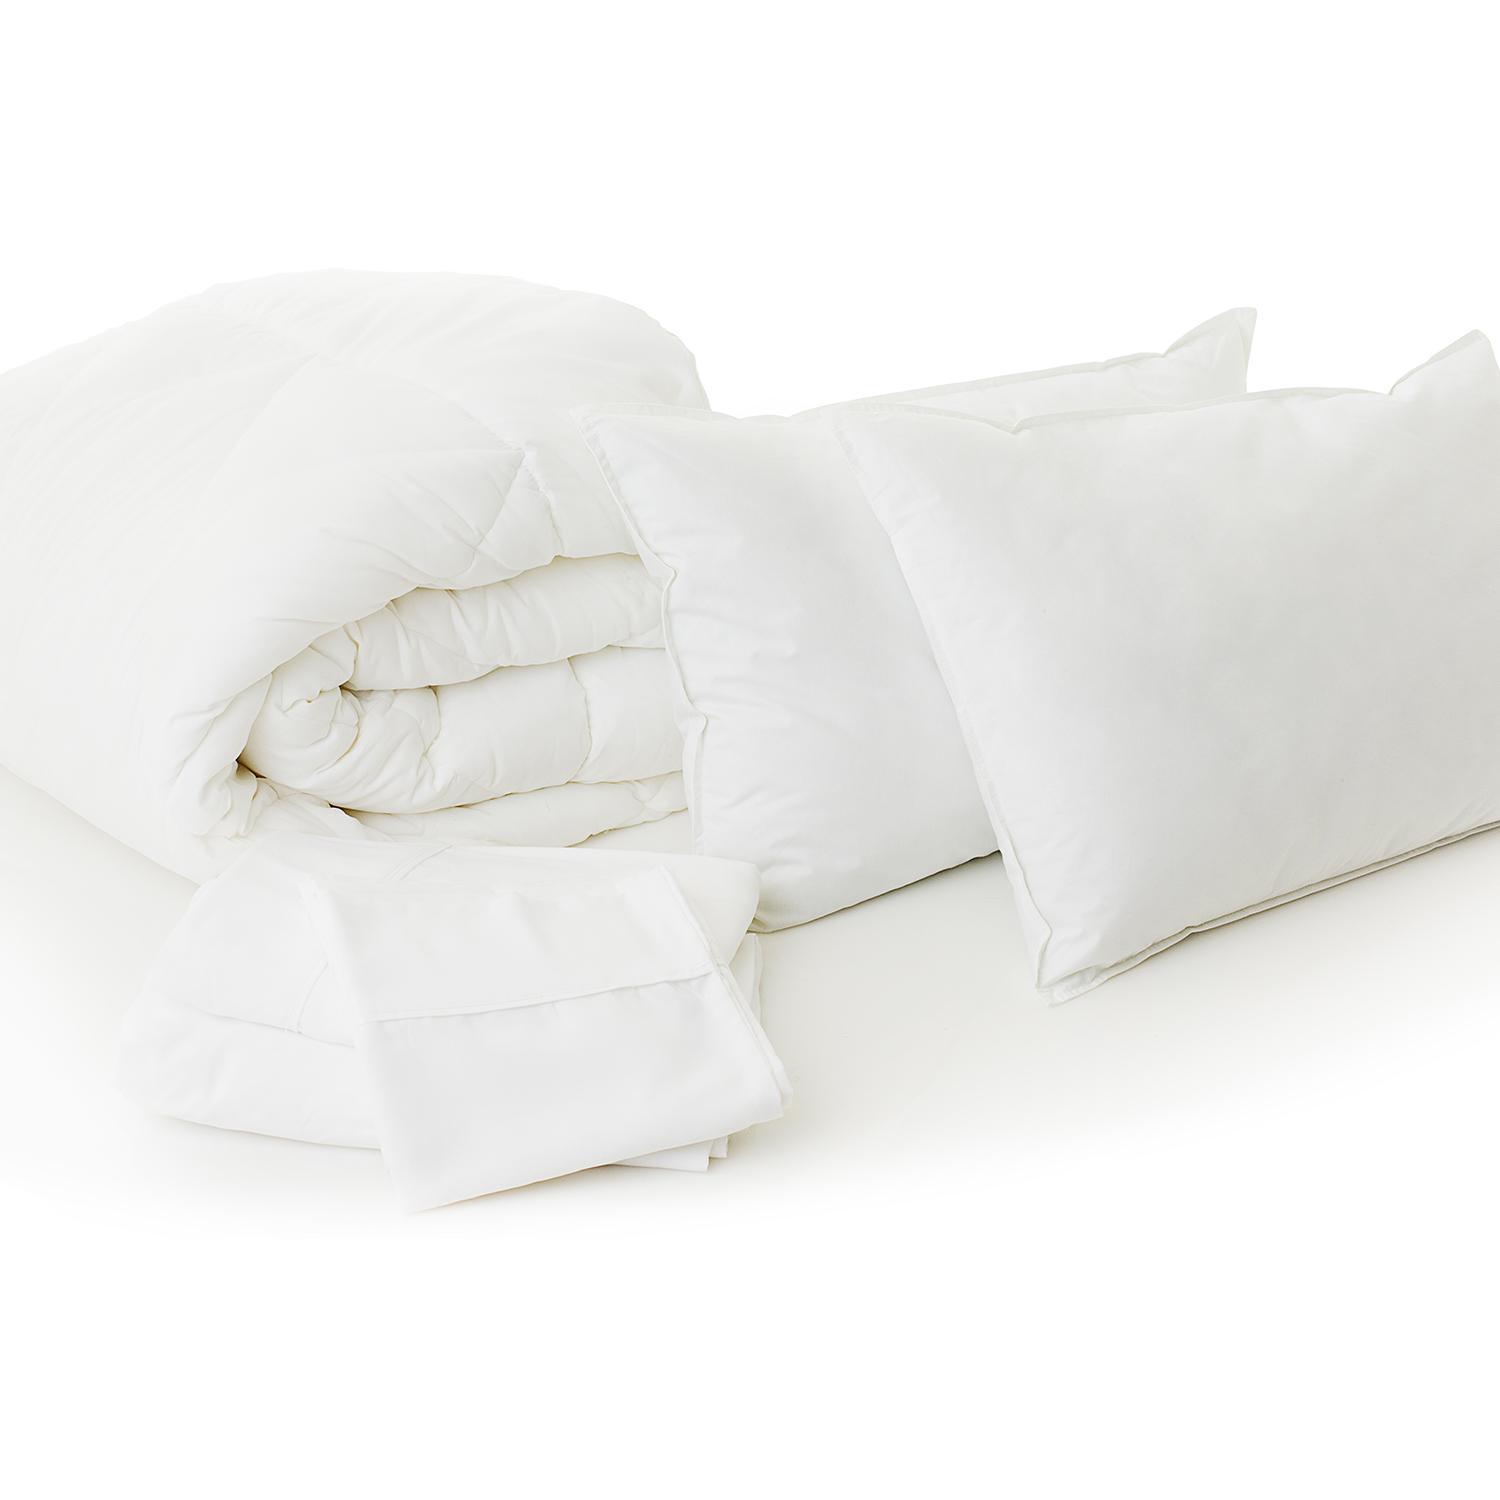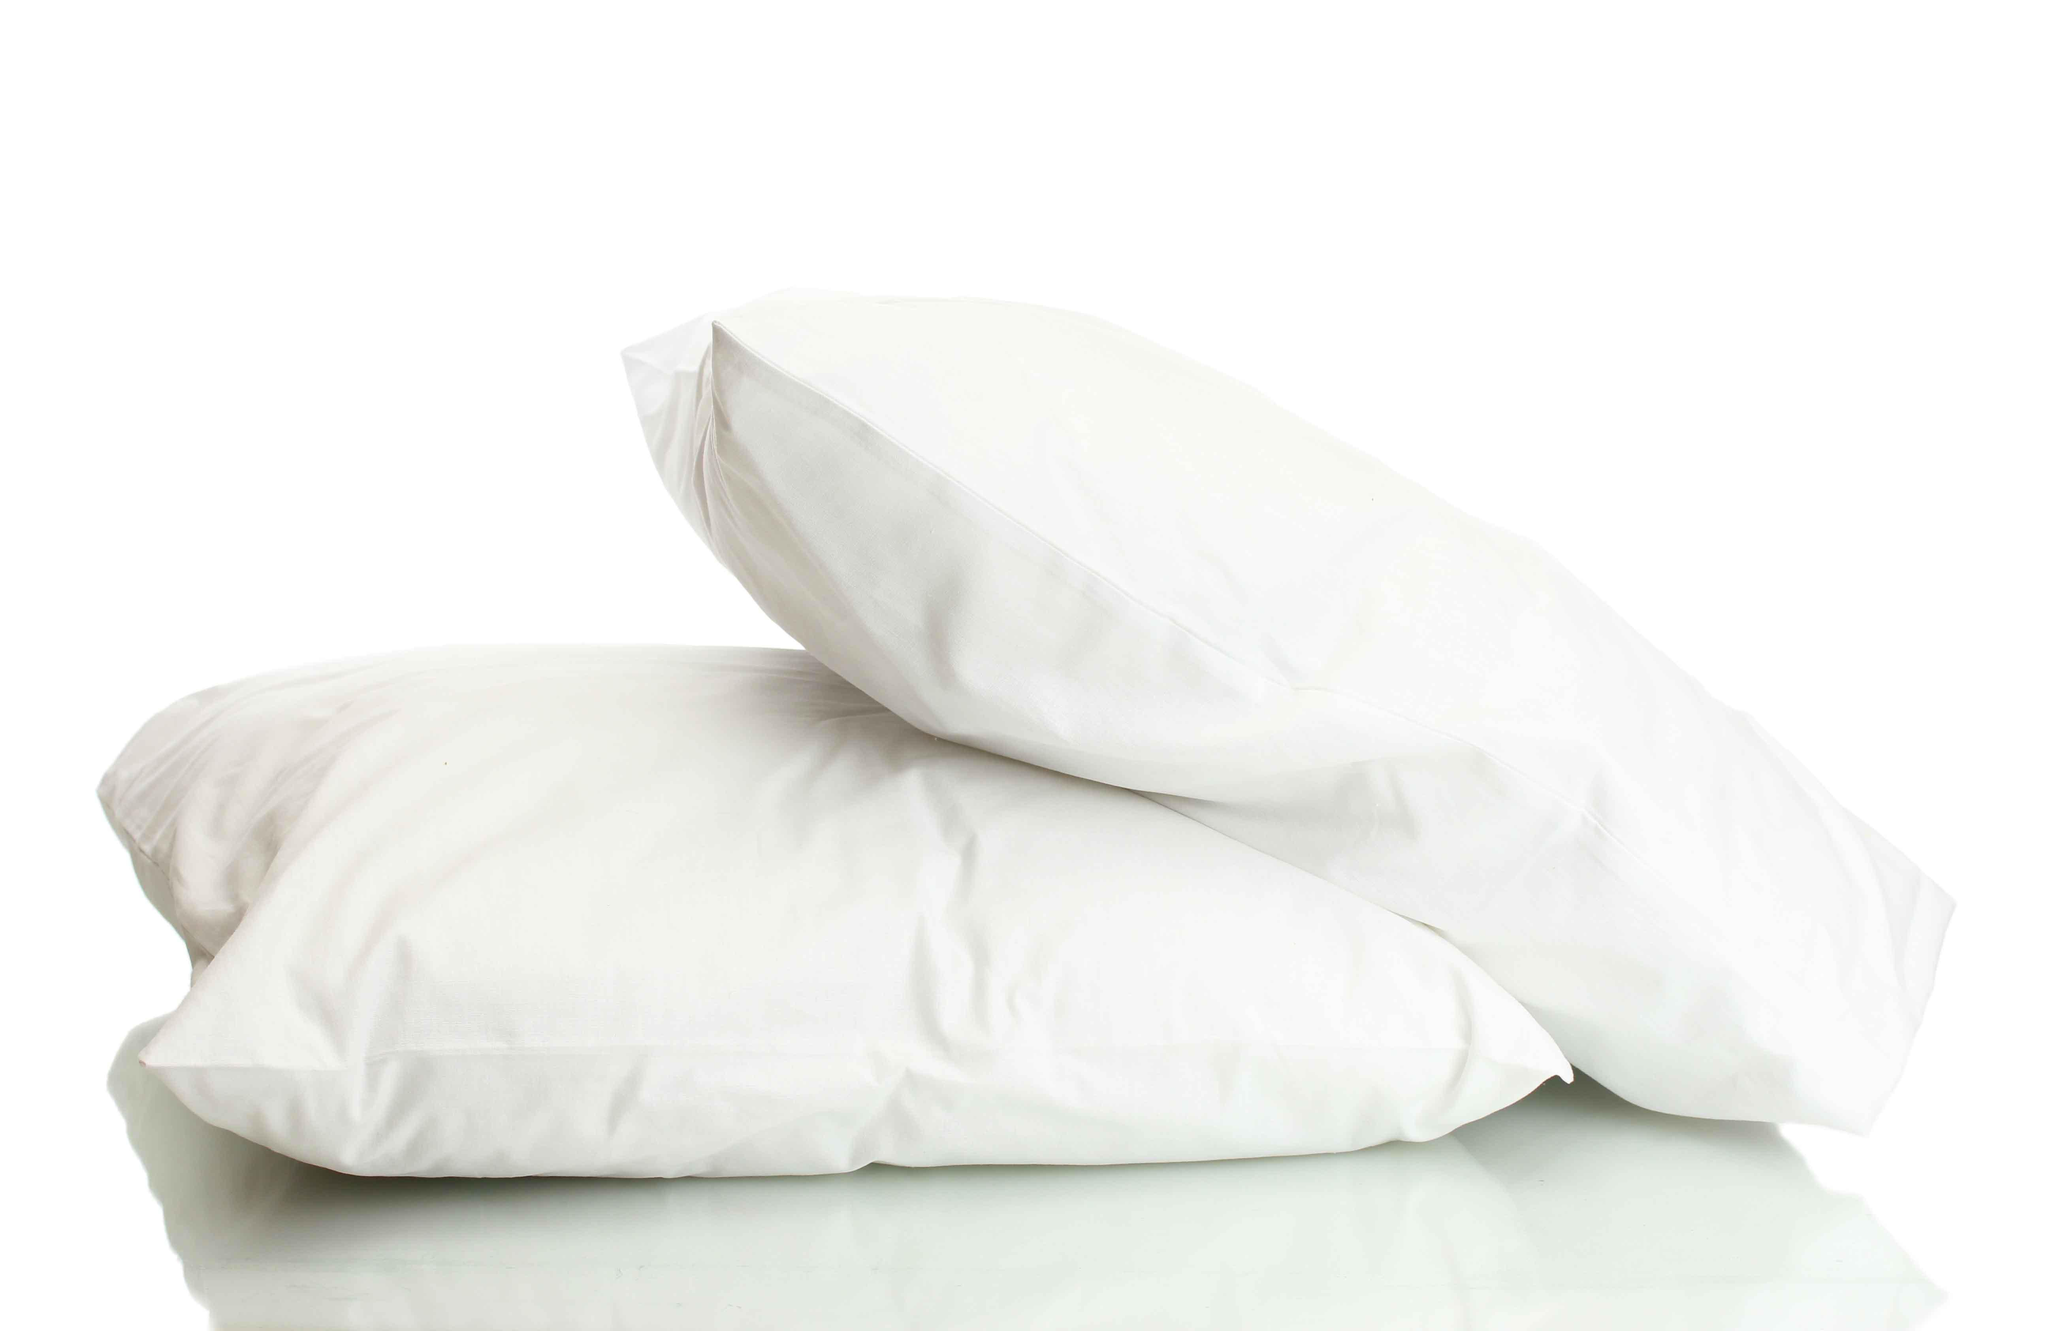The first image is the image on the left, the second image is the image on the right. For the images displayed, is the sentence "There is only one pillow in one of the images." factually correct? Answer yes or no. No. The first image is the image on the left, the second image is the image on the right. Examine the images to the left and right. Is the description "There are three pillows in the pair of images." accurate? Answer yes or no. No. 